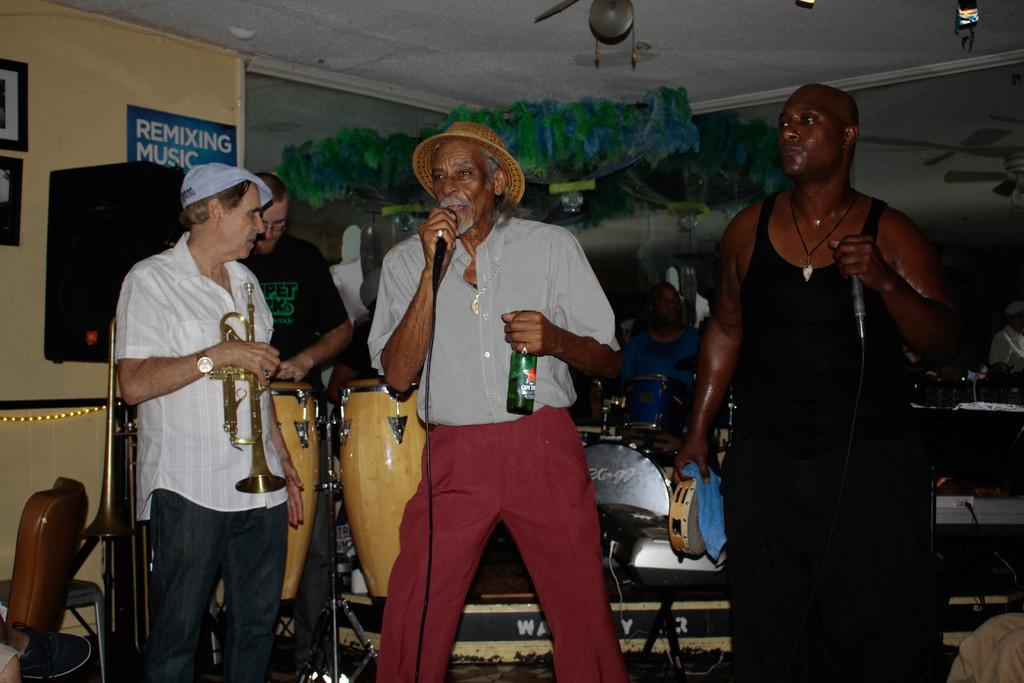How would you summarize this image in a sentence or two? In the image we can see few persons were standing and holding microphone. And the center person holding wine bottle. And rest of the persons were holding some musical instruments. And they were surrounded by some musical instruments. And some more objects around them. 